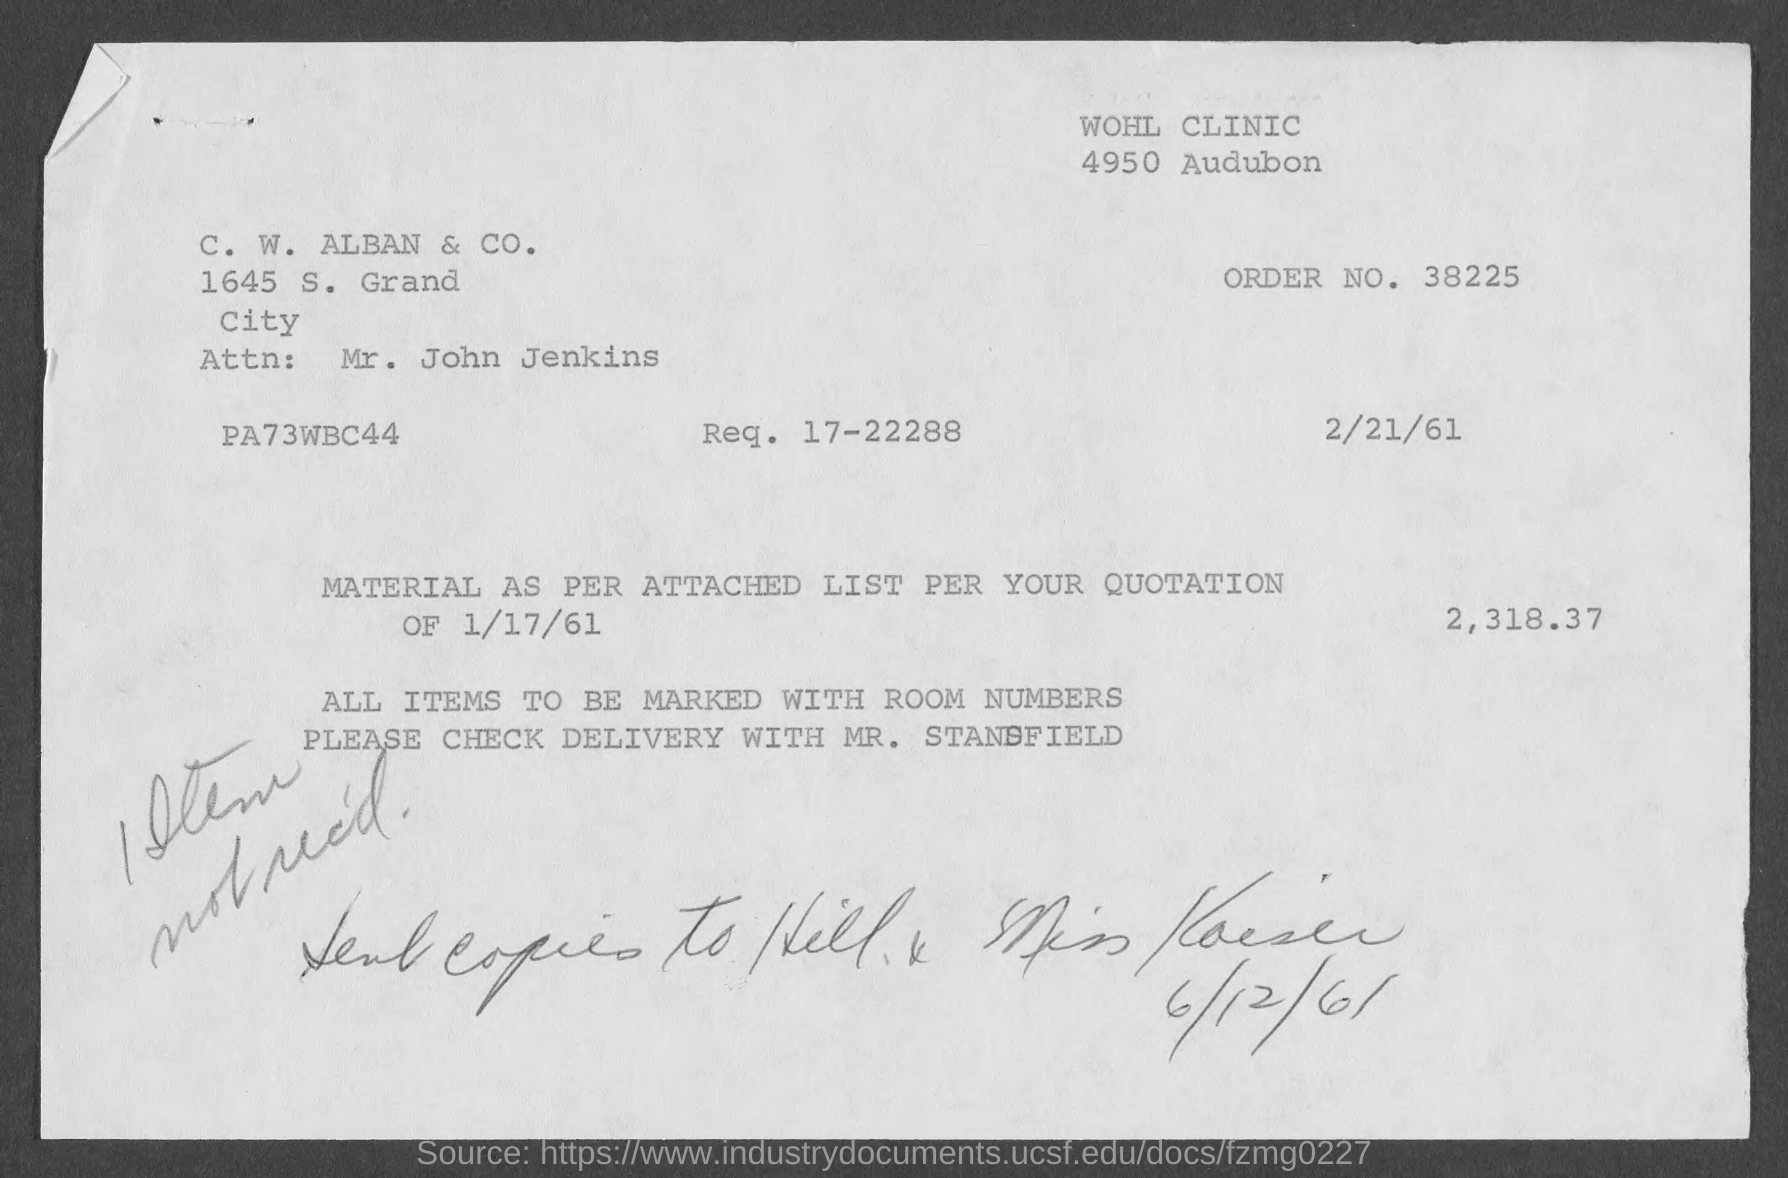What is order no.?
Give a very brief answer. 38225. What is req. no.?
Provide a short and direct response. 17-22288. What is the name of attn. person?
Make the answer very short. Mr. John Jenkins. 